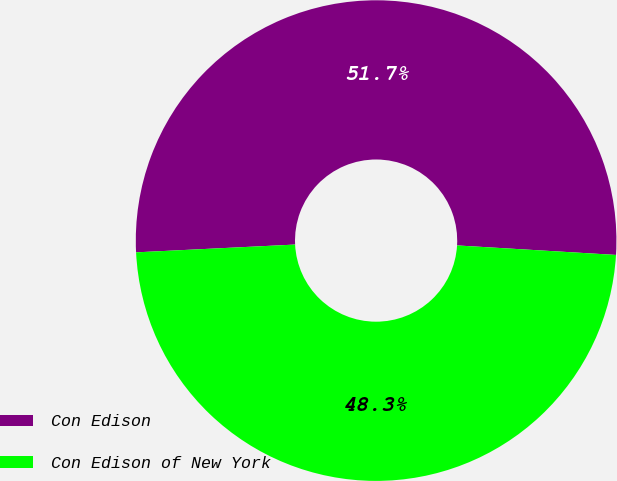Convert chart to OTSL. <chart><loc_0><loc_0><loc_500><loc_500><pie_chart><fcel>Con Edison<fcel>Con Edison of New York<nl><fcel>51.73%<fcel>48.27%<nl></chart> 